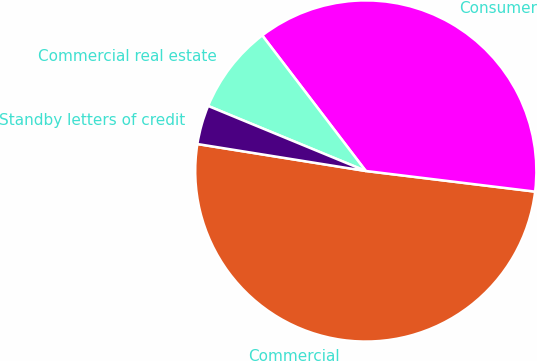Convert chart to OTSL. <chart><loc_0><loc_0><loc_500><loc_500><pie_chart><fcel>Commercial<fcel>Consumer<fcel>Commercial real estate<fcel>Standby letters of credit<nl><fcel>50.59%<fcel>37.31%<fcel>8.39%<fcel>3.7%<nl></chart> 